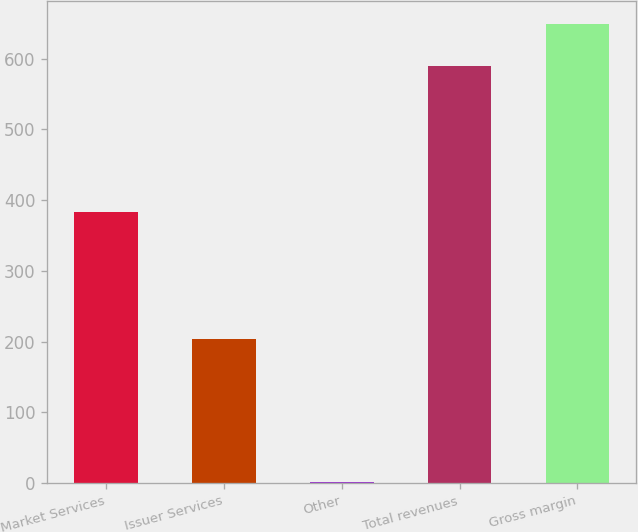Convert chart. <chart><loc_0><loc_0><loc_500><loc_500><bar_chart><fcel>Market Services<fcel>Issuer Services<fcel>Other<fcel>Total revenues<fcel>Gross margin<nl><fcel>383.7<fcel>204.2<fcel>1.9<fcel>589.8<fcel>648.59<nl></chart> 